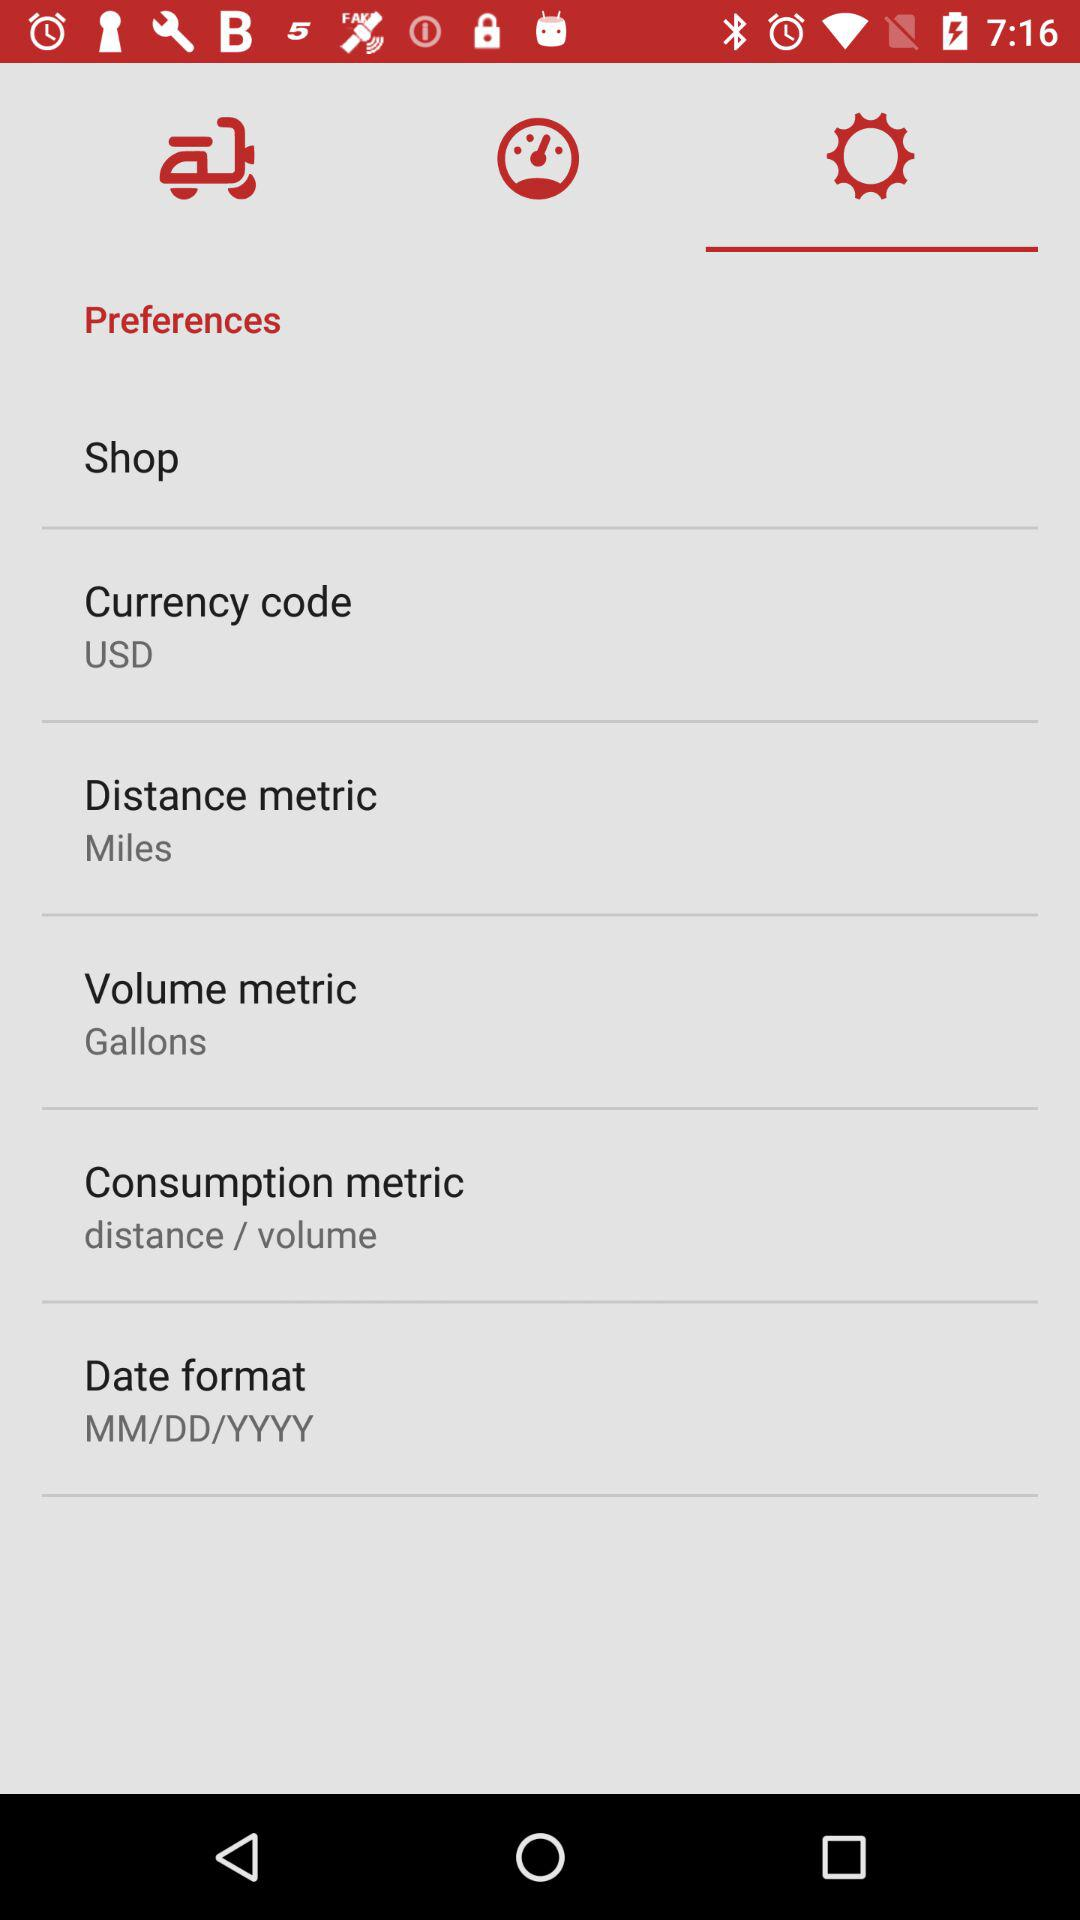What is the unit set for distance metric? The unit set for distance metric is miles. 